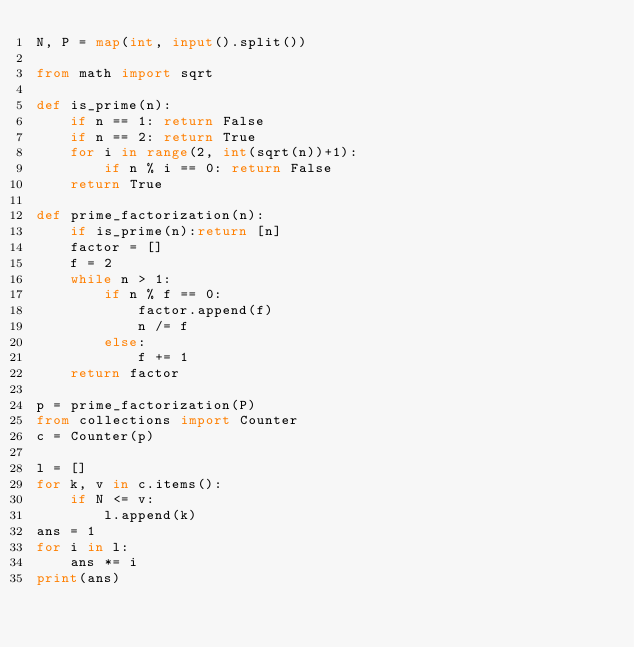Convert code to text. <code><loc_0><loc_0><loc_500><loc_500><_Python_>N, P = map(int, input().split())

from math import sqrt

def is_prime(n):
    if n == 1: return False
    if n == 2: return True
    for i in range(2, int(sqrt(n))+1):
        if n % i == 0: return False
    return True

def prime_factorization(n):
    if is_prime(n):return [n]
    factor = []
    f = 2
    while n > 1:
        if n % f == 0:
            factor.append(f)
            n /= f
        else:
            f += 1
    return factor

p = prime_factorization(P)
from collections import Counter
c = Counter(p)

l = []
for k, v in c.items():
    if N <= v:
        l.append(k)
ans = 1
for i in l:
    ans *= i
print(ans)</code> 